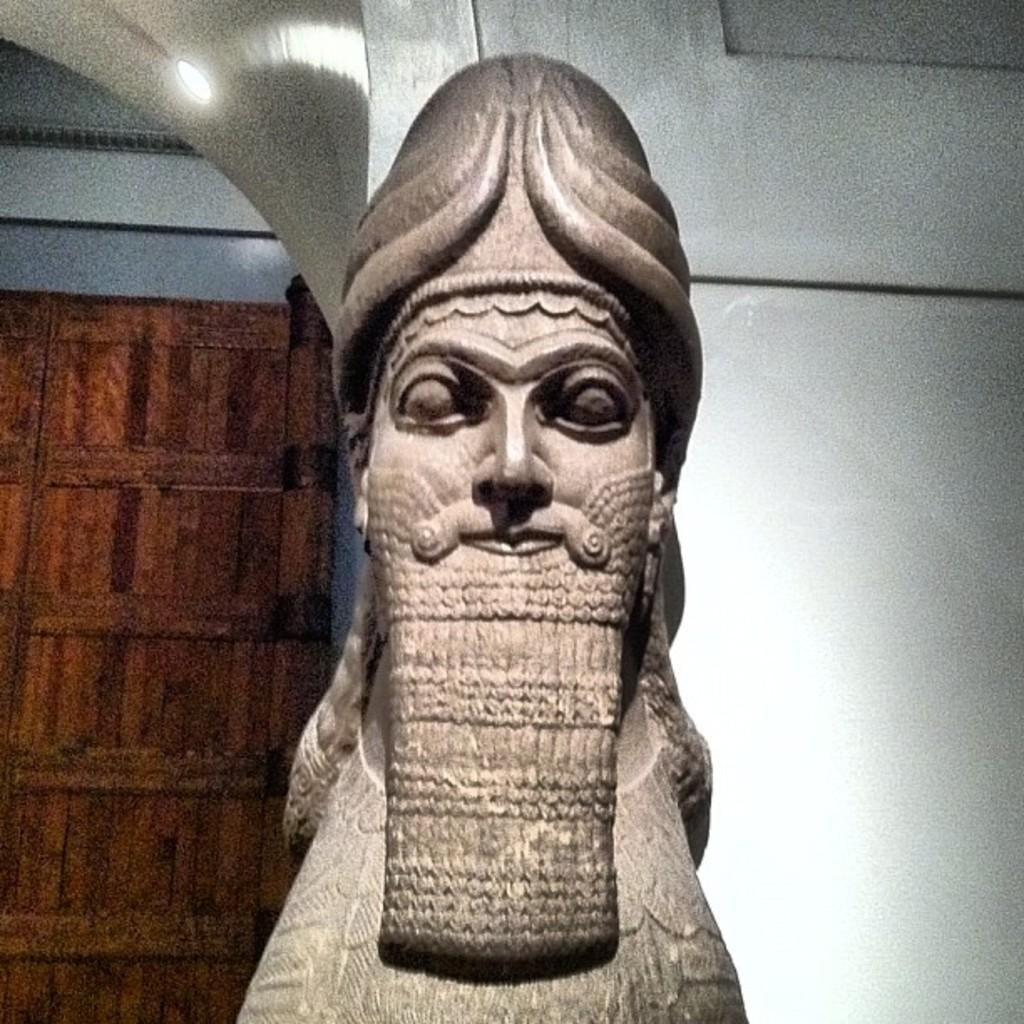What is the main subject in the image? There is a statue in the image. What is behind the statue? There is a wall behind the statue. Can you describe the lighting in the image? There is light in the image. What can be seen in the background of the image? There is a wooden object in the background of the image. What type of wrench is being used in the meeting in the image? There is no wrench or meeting present in the image; it features a statue with a wall behind it and a wooden object in the background. 